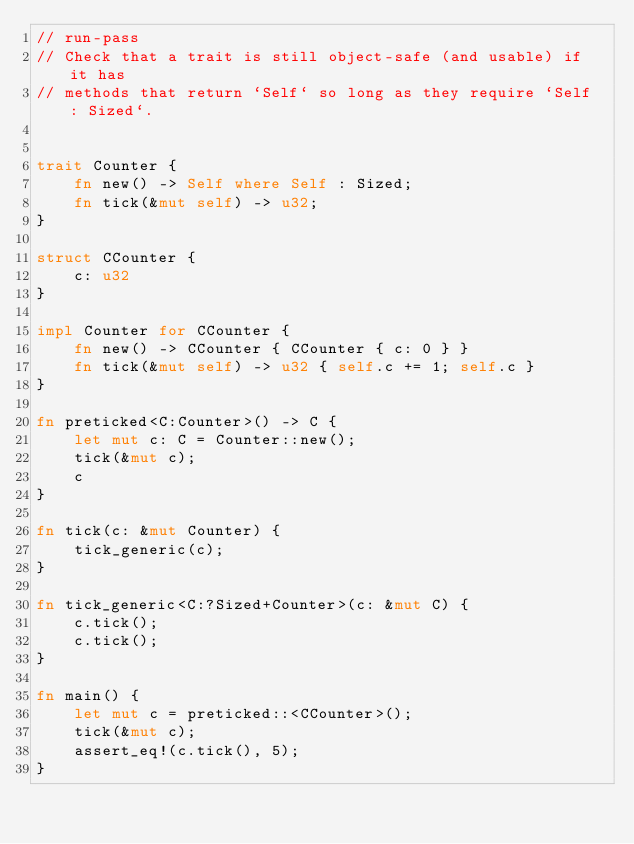<code> <loc_0><loc_0><loc_500><loc_500><_Rust_>// run-pass
// Check that a trait is still object-safe (and usable) if it has
// methods that return `Self` so long as they require `Self : Sized`.


trait Counter {
    fn new() -> Self where Self : Sized;
    fn tick(&mut self) -> u32;
}

struct CCounter {
    c: u32
}

impl Counter for CCounter {
    fn new() -> CCounter { CCounter { c: 0 } }
    fn tick(&mut self) -> u32 { self.c += 1; self.c }
}

fn preticked<C:Counter>() -> C {
    let mut c: C = Counter::new();
    tick(&mut c);
    c
}

fn tick(c: &mut Counter) {
    tick_generic(c);
}

fn tick_generic<C:?Sized+Counter>(c: &mut C) {
    c.tick();
    c.tick();
}

fn main() {
    let mut c = preticked::<CCounter>();
    tick(&mut c);
    assert_eq!(c.tick(), 5);
}
</code> 